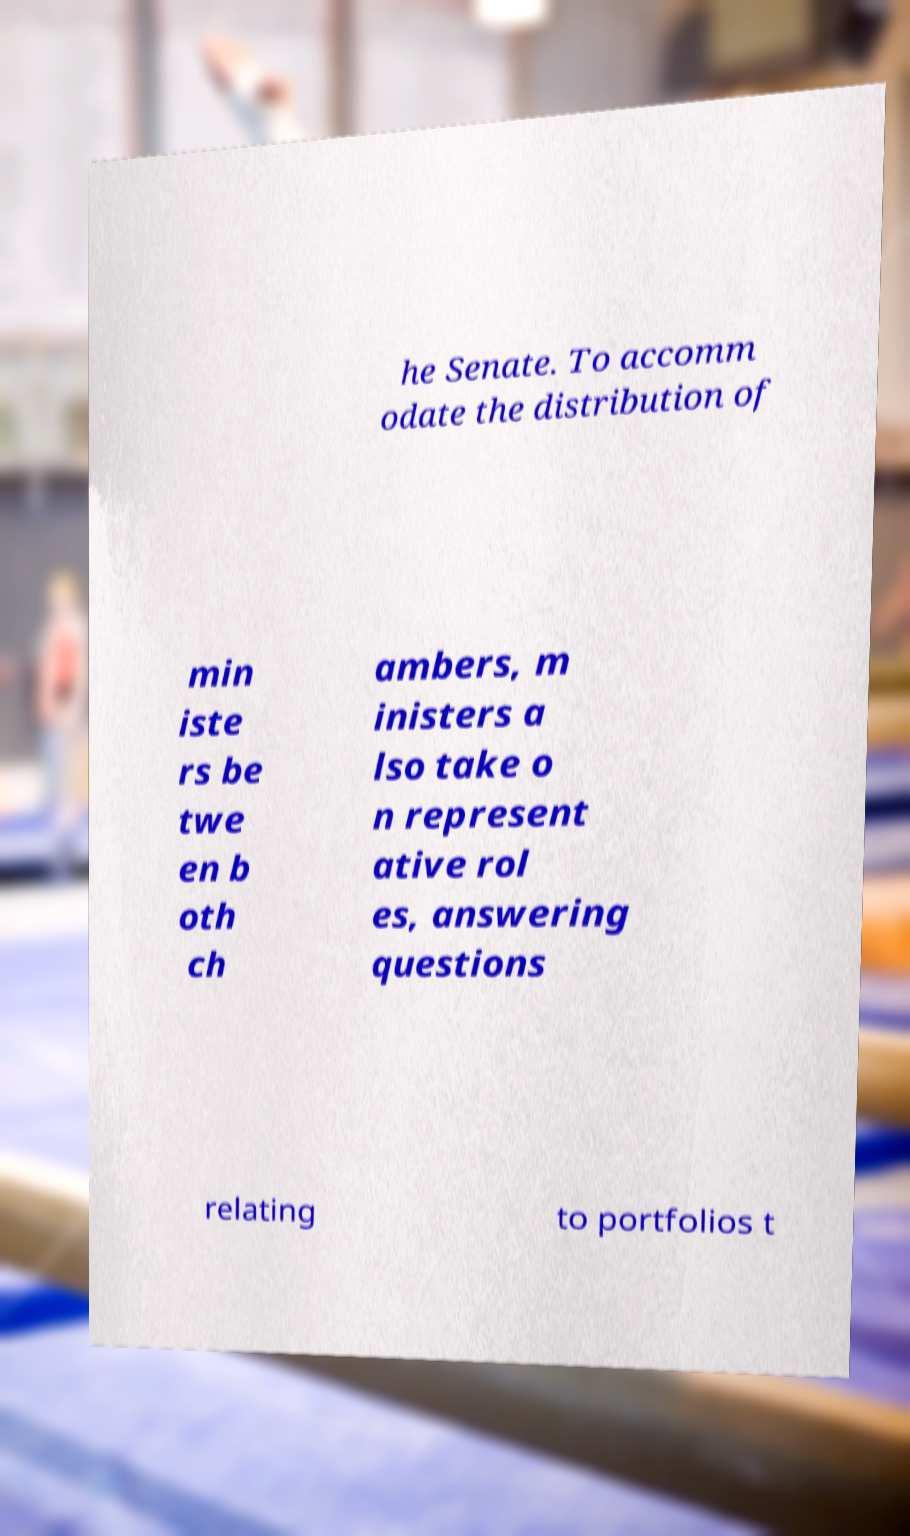Can you read and provide the text displayed in the image?This photo seems to have some interesting text. Can you extract and type it out for me? he Senate. To accomm odate the distribution of min iste rs be twe en b oth ch ambers, m inisters a lso take o n represent ative rol es, answering questions relating to portfolios t 